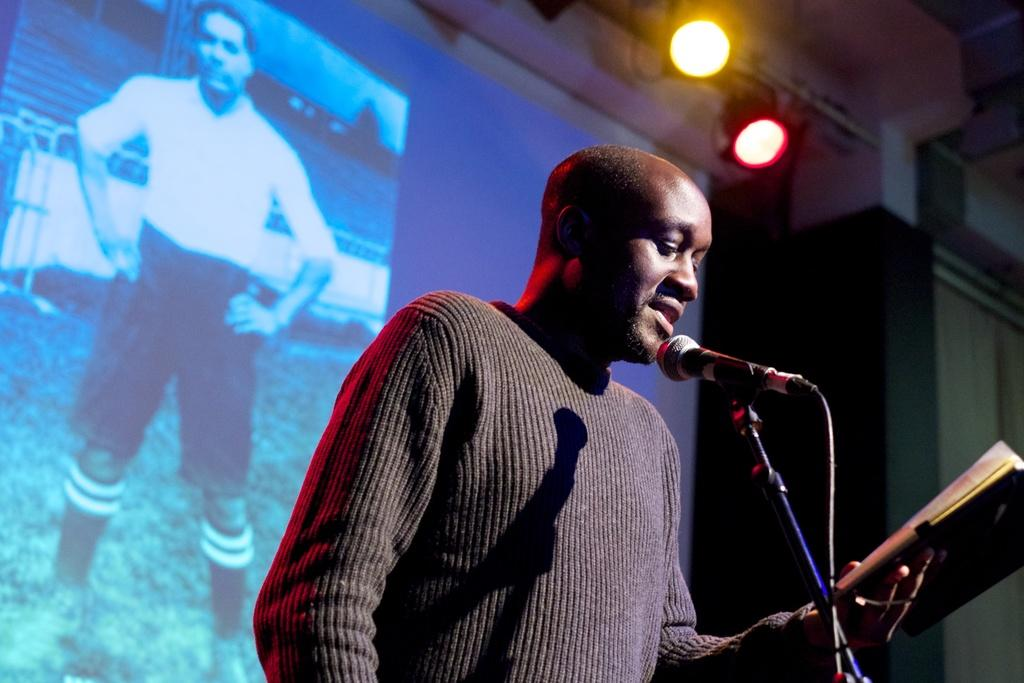What is the main subject of the image? There is a person standing in the image. What is the person holding in the image? The person is holding something. What can be seen in the image that is typically used for amplifying sound? There is a mic in the image. What is present in the image that might be used to hold equipment or documents? There is a stand in the image. What is used for illumination in the image? There are lights in the image. What is present in the image that might display information or visuals? There is a screen in the image. What type of degree is the person holding in the image? There is no degree visible in the image; the person is holding something, but it is not specified as a degree. How many yams are present on the stand in the image? There are no yams present in the image; the stand is holding equipment or documents, not yams. 